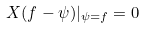<formula> <loc_0><loc_0><loc_500><loc_500>X ( f - \psi ) | _ { \psi = f } = 0</formula> 